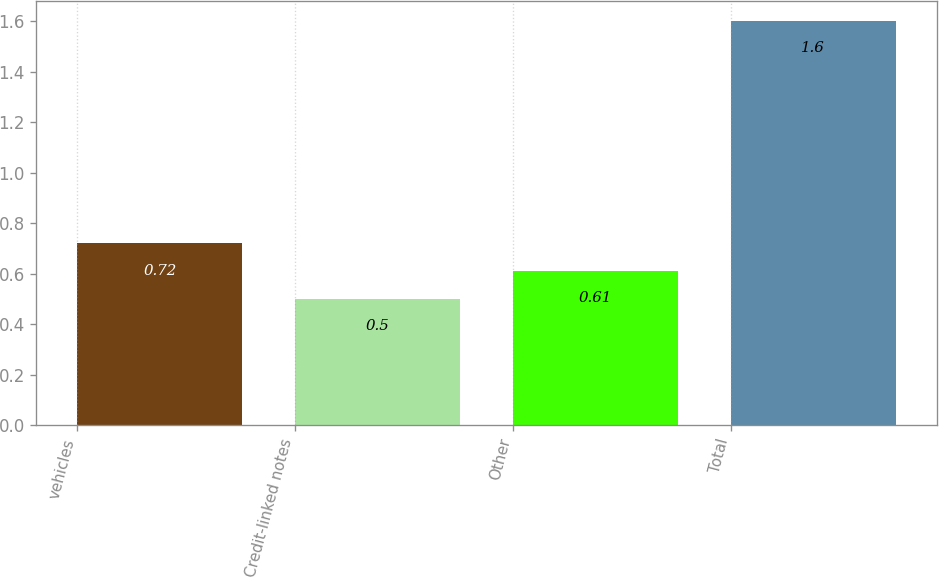Convert chart. <chart><loc_0><loc_0><loc_500><loc_500><bar_chart><fcel>vehicles<fcel>Credit-linked notes<fcel>Other<fcel>Total<nl><fcel>0.72<fcel>0.5<fcel>0.61<fcel>1.6<nl></chart> 